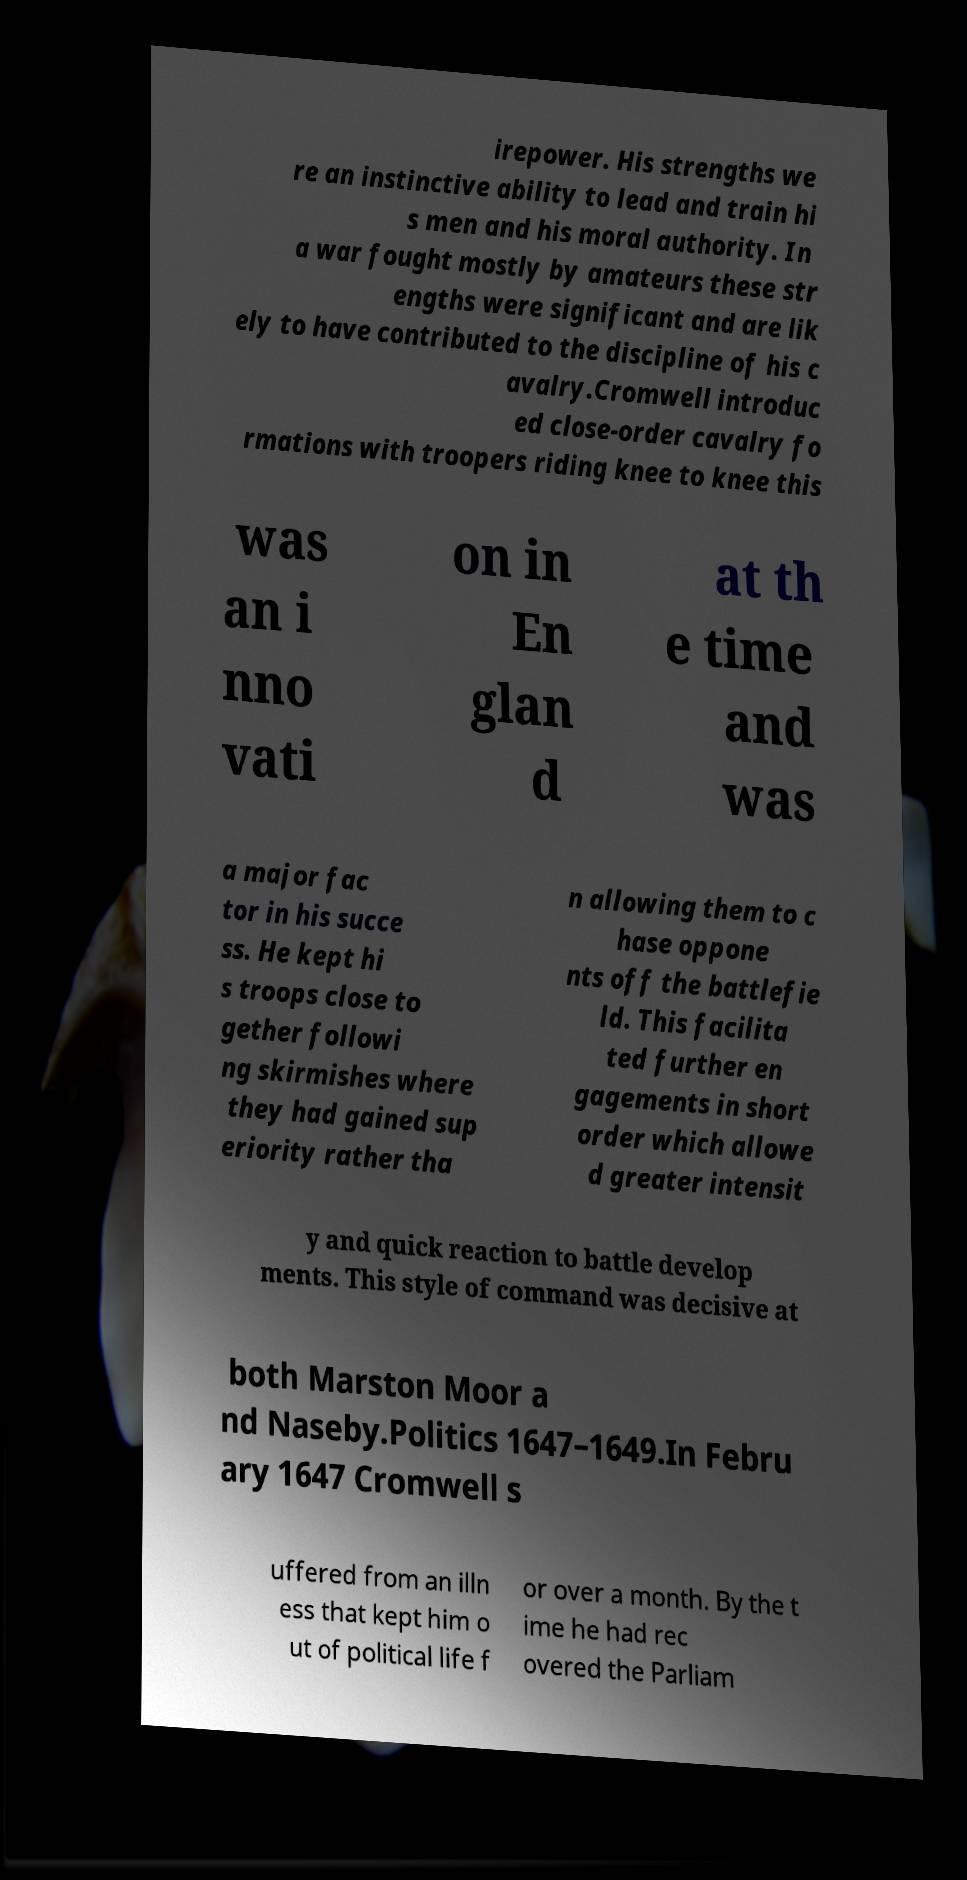Can you accurately transcribe the text from the provided image for me? irepower. His strengths we re an instinctive ability to lead and train hi s men and his moral authority. In a war fought mostly by amateurs these str engths were significant and are lik ely to have contributed to the discipline of his c avalry.Cromwell introduc ed close-order cavalry fo rmations with troopers riding knee to knee this was an i nno vati on in En glan d at th e time and was a major fac tor in his succe ss. He kept hi s troops close to gether followi ng skirmishes where they had gained sup eriority rather tha n allowing them to c hase oppone nts off the battlefie ld. This facilita ted further en gagements in short order which allowe d greater intensit y and quick reaction to battle develop ments. This style of command was decisive at both Marston Moor a nd Naseby.Politics 1647–1649.In Febru ary 1647 Cromwell s uffered from an illn ess that kept him o ut of political life f or over a month. By the t ime he had rec overed the Parliam 